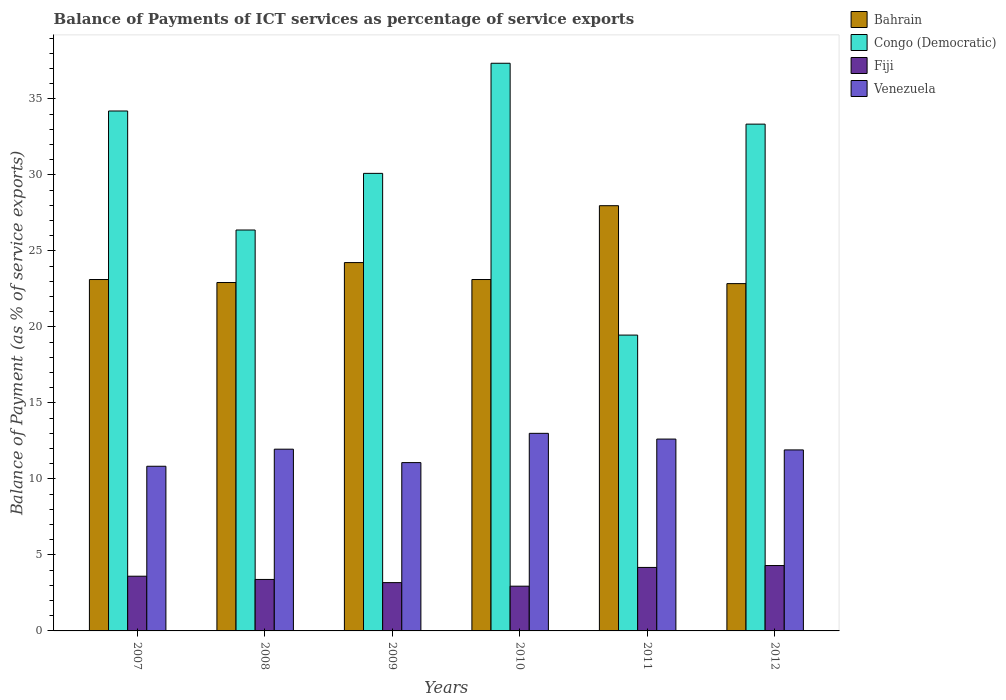Are the number of bars per tick equal to the number of legend labels?
Keep it short and to the point. Yes. Are the number of bars on each tick of the X-axis equal?
Provide a short and direct response. Yes. How many bars are there on the 4th tick from the right?
Your response must be concise. 4. In how many cases, is the number of bars for a given year not equal to the number of legend labels?
Keep it short and to the point. 0. What is the balance of payments of ICT services in Congo (Democratic) in 2009?
Ensure brevity in your answer.  30.1. Across all years, what is the maximum balance of payments of ICT services in Venezuela?
Make the answer very short. 13. Across all years, what is the minimum balance of payments of ICT services in Bahrain?
Your answer should be very brief. 22.84. In which year was the balance of payments of ICT services in Fiji maximum?
Give a very brief answer. 2012. What is the total balance of payments of ICT services in Fiji in the graph?
Provide a short and direct response. 21.58. What is the difference between the balance of payments of ICT services in Venezuela in 2007 and that in 2009?
Keep it short and to the point. -0.24. What is the difference between the balance of payments of ICT services in Venezuela in 2008 and the balance of payments of ICT services in Fiji in 2009?
Provide a short and direct response. 8.78. What is the average balance of payments of ICT services in Congo (Democratic) per year?
Your response must be concise. 30.13. In the year 2007, what is the difference between the balance of payments of ICT services in Congo (Democratic) and balance of payments of ICT services in Fiji?
Your response must be concise. 30.6. What is the ratio of the balance of payments of ICT services in Venezuela in 2007 to that in 2008?
Provide a short and direct response. 0.91. Is the balance of payments of ICT services in Venezuela in 2008 less than that in 2009?
Offer a very short reply. No. What is the difference between the highest and the second highest balance of payments of ICT services in Venezuela?
Your answer should be compact. 0.38. What is the difference between the highest and the lowest balance of payments of ICT services in Fiji?
Make the answer very short. 1.36. In how many years, is the balance of payments of ICT services in Fiji greater than the average balance of payments of ICT services in Fiji taken over all years?
Your response must be concise. 3. What does the 4th bar from the left in 2007 represents?
Your response must be concise. Venezuela. What does the 2nd bar from the right in 2011 represents?
Ensure brevity in your answer.  Fiji. How many years are there in the graph?
Keep it short and to the point. 6. Are the values on the major ticks of Y-axis written in scientific E-notation?
Keep it short and to the point. No. How many legend labels are there?
Offer a terse response. 4. What is the title of the graph?
Provide a succinct answer. Balance of Payments of ICT services as percentage of service exports. What is the label or title of the Y-axis?
Offer a terse response. Balance of Payment (as % of service exports). What is the Balance of Payment (as % of service exports) of Bahrain in 2007?
Provide a succinct answer. 23.11. What is the Balance of Payment (as % of service exports) of Congo (Democratic) in 2007?
Offer a terse response. 34.2. What is the Balance of Payment (as % of service exports) of Fiji in 2007?
Give a very brief answer. 3.6. What is the Balance of Payment (as % of service exports) in Venezuela in 2007?
Ensure brevity in your answer.  10.83. What is the Balance of Payment (as % of service exports) in Bahrain in 2008?
Offer a terse response. 22.92. What is the Balance of Payment (as % of service exports) of Congo (Democratic) in 2008?
Your answer should be very brief. 26.37. What is the Balance of Payment (as % of service exports) in Fiji in 2008?
Offer a very short reply. 3.39. What is the Balance of Payment (as % of service exports) in Venezuela in 2008?
Ensure brevity in your answer.  11.95. What is the Balance of Payment (as % of service exports) in Bahrain in 2009?
Offer a terse response. 24.23. What is the Balance of Payment (as % of service exports) of Congo (Democratic) in 2009?
Your answer should be compact. 30.1. What is the Balance of Payment (as % of service exports) of Fiji in 2009?
Keep it short and to the point. 3.18. What is the Balance of Payment (as % of service exports) of Venezuela in 2009?
Keep it short and to the point. 11.07. What is the Balance of Payment (as % of service exports) of Bahrain in 2010?
Your answer should be compact. 23.11. What is the Balance of Payment (as % of service exports) in Congo (Democratic) in 2010?
Ensure brevity in your answer.  37.34. What is the Balance of Payment (as % of service exports) in Fiji in 2010?
Give a very brief answer. 2.94. What is the Balance of Payment (as % of service exports) of Venezuela in 2010?
Make the answer very short. 13. What is the Balance of Payment (as % of service exports) in Bahrain in 2011?
Ensure brevity in your answer.  27.97. What is the Balance of Payment (as % of service exports) in Congo (Democratic) in 2011?
Keep it short and to the point. 19.46. What is the Balance of Payment (as % of service exports) of Fiji in 2011?
Ensure brevity in your answer.  4.18. What is the Balance of Payment (as % of service exports) in Venezuela in 2011?
Give a very brief answer. 12.62. What is the Balance of Payment (as % of service exports) in Bahrain in 2012?
Offer a very short reply. 22.84. What is the Balance of Payment (as % of service exports) of Congo (Democratic) in 2012?
Give a very brief answer. 33.34. What is the Balance of Payment (as % of service exports) in Fiji in 2012?
Offer a very short reply. 4.3. What is the Balance of Payment (as % of service exports) in Venezuela in 2012?
Offer a very short reply. 11.91. Across all years, what is the maximum Balance of Payment (as % of service exports) in Bahrain?
Provide a short and direct response. 27.97. Across all years, what is the maximum Balance of Payment (as % of service exports) in Congo (Democratic)?
Provide a succinct answer. 37.34. Across all years, what is the maximum Balance of Payment (as % of service exports) of Fiji?
Your answer should be very brief. 4.3. Across all years, what is the maximum Balance of Payment (as % of service exports) of Venezuela?
Your answer should be very brief. 13. Across all years, what is the minimum Balance of Payment (as % of service exports) of Bahrain?
Your response must be concise. 22.84. Across all years, what is the minimum Balance of Payment (as % of service exports) of Congo (Democratic)?
Provide a short and direct response. 19.46. Across all years, what is the minimum Balance of Payment (as % of service exports) of Fiji?
Give a very brief answer. 2.94. Across all years, what is the minimum Balance of Payment (as % of service exports) of Venezuela?
Offer a very short reply. 10.83. What is the total Balance of Payment (as % of service exports) of Bahrain in the graph?
Offer a very short reply. 144.19. What is the total Balance of Payment (as % of service exports) in Congo (Democratic) in the graph?
Ensure brevity in your answer.  180.8. What is the total Balance of Payment (as % of service exports) in Fiji in the graph?
Keep it short and to the point. 21.58. What is the total Balance of Payment (as % of service exports) of Venezuela in the graph?
Offer a very short reply. 71.38. What is the difference between the Balance of Payment (as % of service exports) of Bahrain in 2007 and that in 2008?
Your response must be concise. 0.2. What is the difference between the Balance of Payment (as % of service exports) in Congo (Democratic) in 2007 and that in 2008?
Your answer should be compact. 7.83. What is the difference between the Balance of Payment (as % of service exports) of Fiji in 2007 and that in 2008?
Provide a succinct answer. 0.21. What is the difference between the Balance of Payment (as % of service exports) of Venezuela in 2007 and that in 2008?
Your answer should be compact. -1.12. What is the difference between the Balance of Payment (as % of service exports) of Bahrain in 2007 and that in 2009?
Provide a short and direct response. -1.11. What is the difference between the Balance of Payment (as % of service exports) of Congo (Democratic) in 2007 and that in 2009?
Ensure brevity in your answer.  4.1. What is the difference between the Balance of Payment (as % of service exports) in Fiji in 2007 and that in 2009?
Offer a terse response. 0.42. What is the difference between the Balance of Payment (as % of service exports) in Venezuela in 2007 and that in 2009?
Your answer should be compact. -0.24. What is the difference between the Balance of Payment (as % of service exports) of Congo (Democratic) in 2007 and that in 2010?
Your answer should be very brief. -3.14. What is the difference between the Balance of Payment (as % of service exports) of Fiji in 2007 and that in 2010?
Your response must be concise. 0.66. What is the difference between the Balance of Payment (as % of service exports) of Venezuela in 2007 and that in 2010?
Your answer should be compact. -2.17. What is the difference between the Balance of Payment (as % of service exports) of Bahrain in 2007 and that in 2011?
Offer a very short reply. -4.86. What is the difference between the Balance of Payment (as % of service exports) in Congo (Democratic) in 2007 and that in 2011?
Offer a terse response. 14.74. What is the difference between the Balance of Payment (as % of service exports) of Fiji in 2007 and that in 2011?
Your answer should be very brief. -0.58. What is the difference between the Balance of Payment (as % of service exports) in Venezuela in 2007 and that in 2011?
Your response must be concise. -1.79. What is the difference between the Balance of Payment (as % of service exports) in Bahrain in 2007 and that in 2012?
Your answer should be compact. 0.27. What is the difference between the Balance of Payment (as % of service exports) in Congo (Democratic) in 2007 and that in 2012?
Offer a terse response. 0.86. What is the difference between the Balance of Payment (as % of service exports) of Fiji in 2007 and that in 2012?
Offer a very short reply. -0.7. What is the difference between the Balance of Payment (as % of service exports) in Venezuela in 2007 and that in 2012?
Your answer should be compact. -1.07. What is the difference between the Balance of Payment (as % of service exports) of Bahrain in 2008 and that in 2009?
Keep it short and to the point. -1.31. What is the difference between the Balance of Payment (as % of service exports) of Congo (Democratic) in 2008 and that in 2009?
Offer a very short reply. -3.73. What is the difference between the Balance of Payment (as % of service exports) of Fiji in 2008 and that in 2009?
Give a very brief answer. 0.21. What is the difference between the Balance of Payment (as % of service exports) of Venezuela in 2008 and that in 2009?
Provide a short and direct response. 0.88. What is the difference between the Balance of Payment (as % of service exports) in Bahrain in 2008 and that in 2010?
Your answer should be very brief. -0.2. What is the difference between the Balance of Payment (as % of service exports) in Congo (Democratic) in 2008 and that in 2010?
Provide a short and direct response. -10.97. What is the difference between the Balance of Payment (as % of service exports) in Fiji in 2008 and that in 2010?
Your answer should be very brief. 0.44. What is the difference between the Balance of Payment (as % of service exports) in Venezuela in 2008 and that in 2010?
Your response must be concise. -1.04. What is the difference between the Balance of Payment (as % of service exports) in Bahrain in 2008 and that in 2011?
Make the answer very short. -5.05. What is the difference between the Balance of Payment (as % of service exports) of Congo (Democratic) in 2008 and that in 2011?
Offer a terse response. 6.91. What is the difference between the Balance of Payment (as % of service exports) of Fiji in 2008 and that in 2011?
Provide a succinct answer. -0.79. What is the difference between the Balance of Payment (as % of service exports) of Venezuela in 2008 and that in 2011?
Provide a short and direct response. -0.66. What is the difference between the Balance of Payment (as % of service exports) of Bahrain in 2008 and that in 2012?
Provide a succinct answer. 0.07. What is the difference between the Balance of Payment (as % of service exports) in Congo (Democratic) in 2008 and that in 2012?
Provide a short and direct response. -6.96. What is the difference between the Balance of Payment (as % of service exports) of Fiji in 2008 and that in 2012?
Offer a terse response. -0.91. What is the difference between the Balance of Payment (as % of service exports) of Venezuela in 2008 and that in 2012?
Keep it short and to the point. 0.05. What is the difference between the Balance of Payment (as % of service exports) of Bahrain in 2009 and that in 2010?
Your response must be concise. 1.11. What is the difference between the Balance of Payment (as % of service exports) in Congo (Democratic) in 2009 and that in 2010?
Give a very brief answer. -7.24. What is the difference between the Balance of Payment (as % of service exports) of Fiji in 2009 and that in 2010?
Ensure brevity in your answer.  0.23. What is the difference between the Balance of Payment (as % of service exports) of Venezuela in 2009 and that in 2010?
Offer a terse response. -1.93. What is the difference between the Balance of Payment (as % of service exports) in Bahrain in 2009 and that in 2011?
Your response must be concise. -3.74. What is the difference between the Balance of Payment (as % of service exports) of Congo (Democratic) in 2009 and that in 2011?
Your response must be concise. 10.64. What is the difference between the Balance of Payment (as % of service exports) in Fiji in 2009 and that in 2011?
Your answer should be very brief. -1. What is the difference between the Balance of Payment (as % of service exports) in Venezuela in 2009 and that in 2011?
Your answer should be compact. -1.55. What is the difference between the Balance of Payment (as % of service exports) in Bahrain in 2009 and that in 2012?
Make the answer very short. 1.38. What is the difference between the Balance of Payment (as % of service exports) in Congo (Democratic) in 2009 and that in 2012?
Give a very brief answer. -3.24. What is the difference between the Balance of Payment (as % of service exports) in Fiji in 2009 and that in 2012?
Offer a very short reply. -1.12. What is the difference between the Balance of Payment (as % of service exports) in Venezuela in 2009 and that in 2012?
Offer a terse response. -0.83. What is the difference between the Balance of Payment (as % of service exports) of Bahrain in 2010 and that in 2011?
Offer a terse response. -4.86. What is the difference between the Balance of Payment (as % of service exports) of Congo (Democratic) in 2010 and that in 2011?
Keep it short and to the point. 17.88. What is the difference between the Balance of Payment (as % of service exports) in Fiji in 2010 and that in 2011?
Your answer should be very brief. -1.23. What is the difference between the Balance of Payment (as % of service exports) in Venezuela in 2010 and that in 2011?
Offer a very short reply. 0.38. What is the difference between the Balance of Payment (as % of service exports) of Bahrain in 2010 and that in 2012?
Your answer should be very brief. 0.27. What is the difference between the Balance of Payment (as % of service exports) in Congo (Democratic) in 2010 and that in 2012?
Your answer should be very brief. 4. What is the difference between the Balance of Payment (as % of service exports) of Fiji in 2010 and that in 2012?
Your answer should be compact. -1.36. What is the difference between the Balance of Payment (as % of service exports) in Venezuela in 2010 and that in 2012?
Your answer should be compact. 1.09. What is the difference between the Balance of Payment (as % of service exports) in Bahrain in 2011 and that in 2012?
Make the answer very short. 5.12. What is the difference between the Balance of Payment (as % of service exports) of Congo (Democratic) in 2011 and that in 2012?
Provide a short and direct response. -13.88. What is the difference between the Balance of Payment (as % of service exports) of Fiji in 2011 and that in 2012?
Offer a very short reply. -0.12. What is the difference between the Balance of Payment (as % of service exports) in Venezuela in 2011 and that in 2012?
Your response must be concise. 0.71. What is the difference between the Balance of Payment (as % of service exports) in Bahrain in 2007 and the Balance of Payment (as % of service exports) in Congo (Democratic) in 2008?
Your response must be concise. -3.26. What is the difference between the Balance of Payment (as % of service exports) in Bahrain in 2007 and the Balance of Payment (as % of service exports) in Fiji in 2008?
Keep it short and to the point. 19.73. What is the difference between the Balance of Payment (as % of service exports) in Bahrain in 2007 and the Balance of Payment (as % of service exports) in Venezuela in 2008?
Make the answer very short. 11.16. What is the difference between the Balance of Payment (as % of service exports) of Congo (Democratic) in 2007 and the Balance of Payment (as % of service exports) of Fiji in 2008?
Your response must be concise. 30.81. What is the difference between the Balance of Payment (as % of service exports) of Congo (Democratic) in 2007 and the Balance of Payment (as % of service exports) of Venezuela in 2008?
Your response must be concise. 22.25. What is the difference between the Balance of Payment (as % of service exports) of Fiji in 2007 and the Balance of Payment (as % of service exports) of Venezuela in 2008?
Your response must be concise. -8.35. What is the difference between the Balance of Payment (as % of service exports) of Bahrain in 2007 and the Balance of Payment (as % of service exports) of Congo (Democratic) in 2009?
Your response must be concise. -6.98. What is the difference between the Balance of Payment (as % of service exports) of Bahrain in 2007 and the Balance of Payment (as % of service exports) of Fiji in 2009?
Provide a succinct answer. 19.94. What is the difference between the Balance of Payment (as % of service exports) of Bahrain in 2007 and the Balance of Payment (as % of service exports) of Venezuela in 2009?
Give a very brief answer. 12.04. What is the difference between the Balance of Payment (as % of service exports) of Congo (Democratic) in 2007 and the Balance of Payment (as % of service exports) of Fiji in 2009?
Your response must be concise. 31.02. What is the difference between the Balance of Payment (as % of service exports) in Congo (Democratic) in 2007 and the Balance of Payment (as % of service exports) in Venezuela in 2009?
Provide a succinct answer. 23.13. What is the difference between the Balance of Payment (as % of service exports) of Fiji in 2007 and the Balance of Payment (as % of service exports) of Venezuela in 2009?
Ensure brevity in your answer.  -7.47. What is the difference between the Balance of Payment (as % of service exports) of Bahrain in 2007 and the Balance of Payment (as % of service exports) of Congo (Democratic) in 2010?
Offer a very short reply. -14.22. What is the difference between the Balance of Payment (as % of service exports) in Bahrain in 2007 and the Balance of Payment (as % of service exports) in Fiji in 2010?
Provide a short and direct response. 20.17. What is the difference between the Balance of Payment (as % of service exports) of Bahrain in 2007 and the Balance of Payment (as % of service exports) of Venezuela in 2010?
Give a very brief answer. 10.12. What is the difference between the Balance of Payment (as % of service exports) of Congo (Democratic) in 2007 and the Balance of Payment (as % of service exports) of Fiji in 2010?
Provide a succinct answer. 31.26. What is the difference between the Balance of Payment (as % of service exports) of Congo (Democratic) in 2007 and the Balance of Payment (as % of service exports) of Venezuela in 2010?
Your answer should be compact. 21.2. What is the difference between the Balance of Payment (as % of service exports) in Fiji in 2007 and the Balance of Payment (as % of service exports) in Venezuela in 2010?
Keep it short and to the point. -9.4. What is the difference between the Balance of Payment (as % of service exports) in Bahrain in 2007 and the Balance of Payment (as % of service exports) in Congo (Democratic) in 2011?
Make the answer very short. 3.65. What is the difference between the Balance of Payment (as % of service exports) in Bahrain in 2007 and the Balance of Payment (as % of service exports) in Fiji in 2011?
Provide a succinct answer. 18.94. What is the difference between the Balance of Payment (as % of service exports) of Bahrain in 2007 and the Balance of Payment (as % of service exports) of Venezuela in 2011?
Your response must be concise. 10.5. What is the difference between the Balance of Payment (as % of service exports) in Congo (Democratic) in 2007 and the Balance of Payment (as % of service exports) in Fiji in 2011?
Ensure brevity in your answer.  30.02. What is the difference between the Balance of Payment (as % of service exports) of Congo (Democratic) in 2007 and the Balance of Payment (as % of service exports) of Venezuela in 2011?
Ensure brevity in your answer.  21.58. What is the difference between the Balance of Payment (as % of service exports) of Fiji in 2007 and the Balance of Payment (as % of service exports) of Venezuela in 2011?
Your response must be concise. -9.02. What is the difference between the Balance of Payment (as % of service exports) of Bahrain in 2007 and the Balance of Payment (as % of service exports) of Congo (Democratic) in 2012?
Your answer should be compact. -10.22. What is the difference between the Balance of Payment (as % of service exports) in Bahrain in 2007 and the Balance of Payment (as % of service exports) in Fiji in 2012?
Offer a terse response. 18.81. What is the difference between the Balance of Payment (as % of service exports) in Bahrain in 2007 and the Balance of Payment (as % of service exports) in Venezuela in 2012?
Your response must be concise. 11.21. What is the difference between the Balance of Payment (as % of service exports) in Congo (Democratic) in 2007 and the Balance of Payment (as % of service exports) in Fiji in 2012?
Keep it short and to the point. 29.9. What is the difference between the Balance of Payment (as % of service exports) in Congo (Democratic) in 2007 and the Balance of Payment (as % of service exports) in Venezuela in 2012?
Provide a succinct answer. 22.29. What is the difference between the Balance of Payment (as % of service exports) of Fiji in 2007 and the Balance of Payment (as % of service exports) of Venezuela in 2012?
Give a very brief answer. -8.31. What is the difference between the Balance of Payment (as % of service exports) in Bahrain in 2008 and the Balance of Payment (as % of service exports) in Congo (Democratic) in 2009?
Offer a very short reply. -7.18. What is the difference between the Balance of Payment (as % of service exports) in Bahrain in 2008 and the Balance of Payment (as % of service exports) in Fiji in 2009?
Your response must be concise. 19.74. What is the difference between the Balance of Payment (as % of service exports) of Bahrain in 2008 and the Balance of Payment (as % of service exports) of Venezuela in 2009?
Give a very brief answer. 11.85. What is the difference between the Balance of Payment (as % of service exports) of Congo (Democratic) in 2008 and the Balance of Payment (as % of service exports) of Fiji in 2009?
Offer a very short reply. 23.19. What is the difference between the Balance of Payment (as % of service exports) in Congo (Democratic) in 2008 and the Balance of Payment (as % of service exports) in Venezuela in 2009?
Your response must be concise. 15.3. What is the difference between the Balance of Payment (as % of service exports) in Fiji in 2008 and the Balance of Payment (as % of service exports) in Venezuela in 2009?
Keep it short and to the point. -7.69. What is the difference between the Balance of Payment (as % of service exports) of Bahrain in 2008 and the Balance of Payment (as % of service exports) of Congo (Democratic) in 2010?
Ensure brevity in your answer.  -14.42. What is the difference between the Balance of Payment (as % of service exports) in Bahrain in 2008 and the Balance of Payment (as % of service exports) in Fiji in 2010?
Make the answer very short. 19.97. What is the difference between the Balance of Payment (as % of service exports) of Bahrain in 2008 and the Balance of Payment (as % of service exports) of Venezuela in 2010?
Make the answer very short. 9.92. What is the difference between the Balance of Payment (as % of service exports) in Congo (Democratic) in 2008 and the Balance of Payment (as % of service exports) in Fiji in 2010?
Keep it short and to the point. 23.43. What is the difference between the Balance of Payment (as % of service exports) in Congo (Democratic) in 2008 and the Balance of Payment (as % of service exports) in Venezuela in 2010?
Offer a very short reply. 13.37. What is the difference between the Balance of Payment (as % of service exports) in Fiji in 2008 and the Balance of Payment (as % of service exports) in Venezuela in 2010?
Keep it short and to the point. -9.61. What is the difference between the Balance of Payment (as % of service exports) of Bahrain in 2008 and the Balance of Payment (as % of service exports) of Congo (Democratic) in 2011?
Provide a short and direct response. 3.46. What is the difference between the Balance of Payment (as % of service exports) in Bahrain in 2008 and the Balance of Payment (as % of service exports) in Fiji in 2011?
Make the answer very short. 18.74. What is the difference between the Balance of Payment (as % of service exports) in Bahrain in 2008 and the Balance of Payment (as % of service exports) in Venezuela in 2011?
Your response must be concise. 10.3. What is the difference between the Balance of Payment (as % of service exports) in Congo (Democratic) in 2008 and the Balance of Payment (as % of service exports) in Fiji in 2011?
Ensure brevity in your answer.  22.19. What is the difference between the Balance of Payment (as % of service exports) in Congo (Democratic) in 2008 and the Balance of Payment (as % of service exports) in Venezuela in 2011?
Your answer should be very brief. 13.75. What is the difference between the Balance of Payment (as % of service exports) in Fiji in 2008 and the Balance of Payment (as % of service exports) in Venezuela in 2011?
Offer a terse response. -9.23. What is the difference between the Balance of Payment (as % of service exports) in Bahrain in 2008 and the Balance of Payment (as % of service exports) in Congo (Democratic) in 2012?
Your answer should be very brief. -10.42. What is the difference between the Balance of Payment (as % of service exports) in Bahrain in 2008 and the Balance of Payment (as % of service exports) in Fiji in 2012?
Your answer should be compact. 18.62. What is the difference between the Balance of Payment (as % of service exports) of Bahrain in 2008 and the Balance of Payment (as % of service exports) of Venezuela in 2012?
Your answer should be compact. 11.01. What is the difference between the Balance of Payment (as % of service exports) of Congo (Democratic) in 2008 and the Balance of Payment (as % of service exports) of Fiji in 2012?
Keep it short and to the point. 22.07. What is the difference between the Balance of Payment (as % of service exports) in Congo (Democratic) in 2008 and the Balance of Payment (as % of service exports) in Venezuela in 2012?
Your response must be concise. 14.46. What is the difference between the Balance of Payment (as % of service exports) in Fiji in 2008 and the Balance of Payment (as % of service exports) in Venezuela in 2012?
Your response must be concise. -8.52. What is the difference between the Balance of Payment (as % of service exports) in Bahrain in 2009 and the Balance of Payment (as % of service exports) in Congo (Democratic) in 2010?
Your answer should be compact. -13.11. What is the difference between the Balance of Payment (as % of service exports) in Bahrain in 2009 and the Balance of Payment (as % of service exports) in Fiji in 2010?
Provide a succinct answer. 21.28. What is the difference between the Balance of Payment (as % of service exports) of Bahrain in 2009 and the Balance of Payment (as % of service exports) of Venezuela in 2010?
Keep it short and to the point. 11.23. What is the difference between the Balance of Payment (as % of service exports) of Congo (Democratic) in 2009 and the Balance of Payment (as % of service exports) of Fiji in 2010?
Your response must be concise. 27.15. What is the difference between the Balance of Payment (as % of service exports) in Congo (Democratic) in 2009 and the Balance of Payment (as % of service exports) in Venezuela in 2010?
Your answer should be compact. 17.1. What is the difference between the Balance of Payment (as % of service exports) in Fiji in 2009 and the Balance of Payment (as % of service exports) in Venezuela in 2010?
Provide a short and direct response. -9.82. What is the difference between the Balance of Payment (as % of service exports) in Bahrain in 2009 and the Balance of Payment (as % of service exports) in Congo (Democratic) in 2011?
Provide a succinct answer. 4.77. What is the difference between the Balance of Payment (as % of service exports) in Bahrain in 2009 and the Balance of Payment (as % of service exports) in Fiji in 2011?
Offer a very short reply. 20.05. What is the difference between the Balance of Payment (as % of service exports) in Bahrain in 2009 and the Balance of Payment (as % of service exports) in Venezuela in 2011?
Offer a very short reply. 11.61. What is the difference between the Balance of Payment (as % of service exports) in Congo (Democratic) in 2009 and the Balance of Payment (as % of service exports) in Fiji in 2011?
Make the answer very short. 25.92. What is the difference between the Balance of Payment (as % of service exports) in Congo (Democratic) in 2009 and the Balance of Payment (as % of service exports) in Venezuela in 2011?
Your answer should be very brief. 17.48. What is the difference between the Balance of Payment (as % of service exports) in Fiji in 2009 and the Balance of Payment (as % of service exports) in Venezuela in 2011?
Your answer should be very brief. -9.44. What is the difference between the Balance of Payment (as % of service exports) in Bahrain in 2009 and the Balance of Payment (as % of service exports) in Congo (Democratic) in 2012?
Offer a terse response. -9.11. What is the difference between the Balance of Payment (as % of service exports) of Bahrain in 2009 and the Balance of Payment (as % of service exports) of Fiji in 2012?
Your answer should be very brief. 19.93. What is the difference between the Balance of Payment (as % of service exports) of Bahrain in 2009 and the Balance of Payment (as % of service exports) of Venezuela in 2012?
Make the answer very short. 12.32. What is the difference between the Balance of Payment (as % of service exports) of Congo (Democratic) in 2009 and the Balance of Payment (as % of service exports) of Fiji in 2012?
Ensure brevity in your answer.  25.8. What is the difference between the Balance of Payment (as % of service exports) of Congo (Democratic) in 2009 and the Balance of Payment (as % of service exports) of Venezuela in 2012?
Provide a succinct answer. 18.19. What is the difference between the Balance of Payment (as % of service exports) of Fiji in 2009 and the Balance of Payment (as % of service exports) of Venezuela in 2012?
Your answer should be very brief. -8.73. What is the difference between the Balance of Payment (as % of service exports) in Bahrain in 2010 and the Balance of Payment (as % of service exports) in Congo (Democratic) in 2011?
Provide a short and direct response. 3.65. What is the difference between the Balance of Payment (as % of service exports) in Bahrain in 2010 and the Balance of Payment (as % of service exports) in Fiji in 2011?
Provide a succinct answer. 18.94. What is the difference between the Balance of Payment (as % of service exports) of Bahrain in 2010 and the Balance of Payment (as % of service exports) of Venezuela in 2011?
Your response must be concise. 10.49. What is the difference between the Balance of Payment (as % of service exports) in Congo (Democratic) in 2010 and the Balance of Payment (as % of service exports) in Fiji in 2011?
Offer a terse response. 33.16. What is the difference between the Balance of Payment (as % of service exports) in Congo (Democratic) in 2010 and the Balance of Payment (as % of service exports) in Venezuela in 2011?
Ensure brevity in your answer.  24.72. What is the difference between the Balance of Payment (as % of service exports) in Fiji in 2010 and the Balance of Payment (as % of service exports) in Venezuela in 2011?
Offer a terse response. -9.68. What is the difference between the Balance of Payment (as % of service exports) in Bahrain in 2010 and the Balance of Payment (as % of service exports) in Congo (Democratic) in 2012?
Provide a succinct answer. -10.22. What is the difference between the Balance of Payment (as % of service exports) in Bahrain in 2010 and the Balance of Payment (as % of service exports) in Fiji in 2012?
Ensure brevity in your answer.  18.81. What is the difference between the Balance of Payment (as % of service exports) of Bahrain in 2010 and the Balance of Payment (as % of service exports) of Venezuela in 2012?
Give a very brief answer. 11.21. What is the difference between the Balance of Payment (as % of service exports) of Congo (Democratic) in 2010 and the Balance of Payment (as % of service exports) of Fiji in 2012?
Your response must be concise. 33.04. What is the difference between the Balance of Payment (as % of service exports) of Congo (Democratic) in 2010 and the Balance of Payment (as % of service exports) of Venezuela in 2012?
Your answer should be very brief. 25.43. What is the difference between the Balance of Payment (as % of service exports) in Fiji in 2010 and the Balance of Payment (as % of service exports) in Venezuela in 2012?
Give a very brief answer. -8.96. What is the difference between the Balance of Payment (as % of service exports) of Bahrain in 2011 and the Balance of Payment (as % of service exports) of Congo (Democratic) in 2012?
Your answer should be very brief. -5.37. What is the difference between the Balance of Payment (as % of service exports) in Bahrain in 2011 and the Balance of Payment (as % of service exports) in Fiji in 2012?
Your answer should be very brief. 23.67. What is the difference between the Balance of Payment (as % of service exports) of Bahrain in 2011 and the Balance of Payment (as % of service exports) of Venezuela in 2012?
Keep it short and to the point. 16.06. What is the difference between the Balance of Payment (as % of service exports) of Congo (Democratic) in 2011 and the Balance of Payment (as % of service exports) of Fiji in 2012?
Make the answer very short. 15.16. What is the difference between the Balance of Payment (as % of service exports) in Congo (Democratic) in 2011 and the Balance of Payment (as % of service exports) in Venezuela in 2012?
Offer a terse response. 7.55. What is the difference between the Balance of Payment (as % of service exports) of Fiji in 2011 and the Balance of Payment (as % of service exports) of Venezuela in 2012?
Keep it short and to the point. -7.73. What is the average Balance of Payment (as % of service exports) of Bahrain per year?
Your answer should be compact. 24.03. What is the average Balance of Payment (as % of service exports) of Congo (Democratic) per year?
Provide a succinct answer. 30.13. What is the average Balance of Payment (as % of service exports) of Fiji per year?
Offer a terse response. 3.6. What is the average Balance of Payment (as % of service exports) in Venezuela per year?
Offer a very short reply. 11.9. In the year 2007, what is the difference between the Balance of Payment (as % of service exports) in Bahrain and Balance of Payment (as % of service exports) in Congo (Democratic)?
Your response must be concise. -11.09. In the year 2007, what is the difference between the Balance of Payment (as % of service exports) of Bahrain and Balance of Payment (as % of service exports) of Fiji?
Provide a short and direct response. 19.52. In the year 2007, what is the difference between the Balance of Payment (as % of service exports) in Bahrain and Balance of Payment (as % of service exports) in Venezuela?
Make the answer very short. 12.28. In the year 2007, what is the difference between the Balance of Payment (as % of service exports) of Congo (Democratic) and Balance of Payment (as % of service exports) of Fiji?
Offer a terse response. 30.6. In the year 2007, what is the difference between the Balance of Payment (as % of service exports) in Congo (Democratic) and Balance of Payment (as % of service exports) in Venezuela?
Provide a succinct answer. 23.37. In the year 2007, what is the difference between the Balance of Payment (as % of service exports) in Fiji and Balance of Payment (as % of service exports) in Venezuela?
Your answer should be compact. -7.23. In the year 2008, what is the difference between the Balance of Payment (as % of service exports) of Bahrain and Balance of Payment (as % of service exports) of Congo (Democratic)?
Offer a terse response. -3.45. In the year 2008, what is the difference between the Balance of Payment (as % of service exports) of Bahrain and Balance of Payment (as % of service exports) of Fiji?
Provide a short and direct response. 19.53. In the year 2008, what is the difference between the Balance of Payment (as % of service exports) of Bahrain and Balance of Payment (as % of service exports) of Venezuela?
Provide a succinct answer. 10.96. In the year 2008, what is the difference between the Balance of Payment (as % of service exports) of Congo (Democratic) and Balance of Payment (as % of service exports) of Fiji?
Your answer should be very brief. 22.98. In the year 2008, what is the difference between the Balance of Payment (as % of service exports) of Congo (Democratic) and Balance of Payment (as % of service exports) of Venezuela?
Your response must be concise. 14.42. In the year 2008, what is the difference between the Balance of Payment (as % of service exports) in Fiji and Balance of Payment (as % of service exports) in Venezuela?
Make the answer very short. -8.57. In the year 2009, what is the difference between the Balance of Payment (as % of service exports) in Bahrain and Balance of Payment (as % of service exports) in Congo (Democratic)?
Make the answer very short. -5.87. In the year 2009, what is the difference between the Balance of Payment (as % of service exports) of Bahrain and Balance of Payment (as % of service exports) of Fiji?
Your answer should be compact. 21.05. In the year 2009, what is the difference between the Balance of Payment (as % of service exports) in Bahrain and Balance of Payment (as % of service exports) in Venezuela?
Keep it short and to the point. 13.16. In the year 2009, what is the difference between the Balance of Payment (as % of service exports) of Congo (Democratic) and Balance of Payment (as % of service exports) of Fiji?
Give a very brief answer. 26.92. In the year 2009, what is the difference between the Balance of Payment (as % of service exports) of Congo (Democratic) and Balance of Payment (as % of service exports) of Venezuela?
Provide a short and direct response. 19.03. In the year 2009, what is the difference between the Balance of Payment (as % of service exports) of Fiji and Balance of Payment (as % of service exports) of Venezuela?
Provide a short and direct response. -7.89. In the year 2010, what is the difference between the Balance of Payment (as % of service exports) in Bahrain and Balance of Payment (as % of service exports) in Congo (Democratic)?
Your response must be concise. -14.23. In the year 2010, what is the difference between the Balance of Payment (as % of service exports) of Bahrain and Balance of Payment (as % of service exports) of Fiji?
Ensure brevity in your answer.  20.17. In the year 2010, what is the difference between the Balance of Payment (as % of service exports) of Bahrain and Balance of Payment (as % of service exports) of Venezuela?
Your answer should be compact. 10.12. In the year 2010, what is the difference between the Balance of Payment (as % of service exports) in Congo (Democratic) and Balance of Payment (as % of service exports) in Fiji?
Provide a succinct answer. 34.4. In the year 2010, what is the difference between the Balance of Payment (as % of service exports) in Congo (Democratic) and Balance of Payment (as % of service exports) in Venezuela?
Provide a short and direct response. 24.34. In the year 2010, what is the difference between the Balance of Payment (as % of service exports) in Fiji and Balance of Payment (as % of service exports) in Venezuela?
Provide a succinct answer. -10.05. In the year 2011, what is the difference between the Balance of Payment (as % of service exports) of Bahrain and Balance of Payment (as % of service exports) of Congo (Democratic)?
Make the answer very short. 8.51. In the year 2011, what is the difference between the Balance of Payment (as % of service exports) in Bahrain and Balance of Payment (as % of service exports) in Fiji?
Ensure brevity in your answer.  23.79. In the year 2011, what is the difference between the Balance of Payment (as % of service exports) in Bahrain and Balance of Payment (as % of service exports) in Venezuela?
Your answer should be compact. 15.35. In the year 2011, what is the difference between the Balance of Payment (as % of service exports) of Congo (Democratic) and Balance of Payment (as % of service exports) of Fiji?
Provide a short and direct response. 15.28. In the year 2011, what is the difference between the Balance of Payment (as % of service exports) in Congo (Democratic) and Balance of Payment (as % of service exports) in Venezuela?
Provide a succinct answer. 6.84. In the year 2011, what is the difference between the Balance of Payment (as % of service exports) in Fiji and Balance of Payment (as % of service exports) in Venezuela?
Your response must be concise. -8.44. In the year 2012, what is the difference between the Balance of Payment (as % of service exports) of Bahrain and Balance of Payment (as % of service exports) of Congo (Democratic)?
Make the answer very short. -10.49. In the year 2012, what is the difference between the Balance of Payment (as % of service exports) in Bahrain and Balance of Payment (as % of service exports) in Fiji?
Keep it short and to the point. 18.54. In the year 2012, what is the difference between the Balance of Payment (as % of service exports) of Bahrain and Balance of Payment (as % of service exports) of Venezuela?
Offer a very short reply. 10.94. In the year 2012, what is the difference between the Balance of Payment (as % of service exports) in Congo (Democratic) and Balance of Payment (as % of service exports) in Fiji?
Offer a very short reply. 29.03. In the year 2012, what is the difference between the Balance of Payment (as % of service exports) in Congo (Democratic) and Balance of Payment (as % of service exports) in Venezuela?
Provide a short and direct response. 21.43. In the year 2012, what is the difference between the Balance of Payment (as % of service exports) of Fiji and Balance of Payment (as % of service exports) of Venezuela?
Give a very brief answer. -7.61. What is the ratio of the Balance of Payment (as % of service exports) in Bahrain in 2007 to that in 2008?
Make the answer very short. 1.01. What is the ratio of the Balance of Payment (as % of service exports) in Congo (Democratic) in 2007 to that in 2008?
Offer a very short reply. 1.3. What is the ratio of the Balance of Payment (as % of service exports) in Fiji in 2007 to that in 2008?
Give a very brief answer. 1.06. What is the ratio of the Balance of Payment (as % of service exports) of Venezuela in 2007 to that in 2008?
Your answer should be very brief. 0.91. What is the ratio of the Balance of Payment (as % of service exports) of Bahrain in 2007 to that in 2009?
Make the answer very short. 0.95. What is the ratio of the Balance of Payment (as % of service exports) in Congo (Democratic) in 2007 to that in 2009?
Your answer should be very brief. 1.14. What is the ratio of the Balance of Payment (as % of service exports) in Fiji in 2007 to that in 2009?
Offer a terse response. 1.13. What is the ratio of the Balance of Payment (as % of service exports) of Venezuela in 2007 to that in 2009?
Give a very brief answer. 0.98. What is the ratio of the Balance of Payment (as % of service exports) in Bahrain in 2007 to that in 2010?
Provide a succinct answer. 1. What is the ratio of the Balance of Payment (as % of service exports) of Congo (Democratic) in 2007 to that in 2010?
Provide a succinct answer. 0.92. What is the ratio of the Balance of Payment (as % of service exports) in Fiji in 2007 to that in 2010?
Your response must be concise. 1.22. What is the ratio of the Balance of Payment (as % of service exports) of Venezuela in 2007 to that in 2010?
Offer a very short reply. 0.83. What is the ratio of the Balance of Payment (as % of service exports) of Bahrain in 2007 to that in 2011?
Make the answer very short. 0.83. What is the ratio of the Balance of Payment (as % of service exports) of Congo (Democratic) in 2007 to that in 2011?
Your answer should be very brief. 1.76. What is the ratio of the Balance of Payment (as % of service exports) in Fiji in 2007 to that in 2011?
Your response must be concise. 0.86. What is the ratio of the Balance of Payment (as % of service exports) in Venezuela in 2007 to that in 2011?
Offer a very short reply. 0.86. What is the ratio of the Balance of Payment (as % of service exports) of Bahrain in 2007 to that in 2012?
Offer a very short reply. 1.01. What is the ratio of the Balance of Payment (as % of service exports) of Congo (Democratic) in 2007 to that in 2012?
Offer a very short reply. 1.03. What is the ratio of the Balance of Payment (as % of service exports) in Fiji in 2007 to that in 2012?
Offer a very short reply. 0.84. What is the ratio of the Balance of Payment (as % of service exports) of Venezuela in 2007 to that in 2012?
Your response must be concise. 0.91. What is the ratio of the Balance of Payment (as % of service exports) of Bahrain in 2008 to that in 2009?
Offer a terse response. 0.95. What is the ratio of the Balance of Payment (as % of service exports) in Congo (Democratic) in 2008 to that in 2009?
Your answer should be compact. 0.88. What is the ratio of the Balance of Payment (as % of service exports) in Fiji in 2008 to that in 2009?
Ensure brevity in your answer.  1.07. What is the ratio of the Balance of Payment (as % of service exports) of Venezuela in 2008 to that in 2009?
Make the answer very short. 1.08. What is the ratio of the Balance of Payment (as % of service exports) of Bahrain in 2008 to that in 2010?
Give a very brief answer. 0.99. What is the ratio of the Balance of Payment (as % of service exports) of Congo (Democratic) in 2008 to that in 2010?
Provide a succinct answer. 0.71. What is the ratio of the Balance of Payment (as % of service exports) of Fiji in 2008 to that in 2010?
Offer a terse response. 1.15. What is the ratio of the Balance of Payment (as % of service exports) in Venezuela in 2008 to that in 2010?
Provide a succinct answer. 0.92. What is the ratio of the Balance of Payment (as % of service exports) of Bahrain in 2008 to that in 2011?
Make the answer very short. 0.82. What is the ratio of the Balance of Payment (as % of service exports) of Congo (Democratic) in 2008 to that in 2011?
Offer a terse response. 1.36. What is the ratio of the Balance of Payment (as % of service exports) in Fiji in 2008 to that in 2011?
Make the answer very short. 0.81. What is the ratio of the Balance of Payment (as % of service exports) in Venezuela in 2008 to that in 2011?
Your answer should be very brief. 0.95. What is the ratio of the Balance of Payment (as % of service exports) of Bahrain in 2008 to that in 2012?
Your response must be concise. 1. What is the ratio of the Balance of Payment (as % of service exports) in Congo (Democratic) in 2008 to that in 2012?
Provide a short and direct response. 0.79. What is the ratio of the Balance of Payment (as % of service exports) in Fiji in 2008 to that in 2012?
Ensure brevity in your answer.  0.79. What is the ratio of the Balance of Payment (as % of service exports) in Bahrain in 2009 to that in 2010?
Give a very brief answer. 1.05. What is the ratio of the Balance of Payment (as % of service exports) in Congo (Democratic) in 2009 to that in 2010?
Keep it short and to the point. 0.81. What is the ratio of the Balance of Payment (as % of service exports) of Fiji in 2009 to that in 2010?
Your response must be concise. 1.08. What is the ratio of the Balance of Payment (as % of service exports) in Venezuela in 2009 to that in 2010?
Your response must be concise. 0.85. What is the ratio of the Balance of Payment (as % of service exports) of Bahrain in 2009 to that in 2011?
Give a very brief answer. 0.87. What is the ratio of the Balance of Payment (as % of service exports) in Congo (Democratic) in 2009 to that in 2011?
Keep it short and to the point. 1.55. What is the ratio of the Balance of Payment (as % of service exports) in Fiji in 2009 to that in 2011?
Your answer should be compact. 0.76. What is the ratio of the Balance of Payment (as % of service exports) in Venezuela in 2009 to that in 2011?
Offer a terse response. 0.88. What is the ratio of the Balance of Payment (as % of service exports) in Bahrain in 2009 to that in 2012?
Ensure brevity in your answer.  1.06. What is the ratio of the Balance of Payment (as % of service exports) of Congo (Democratic) in 2009 to that in 2012?
Make the answer very short. 0.9. What is the ratio of the Balance of Payment (as % of service exports) of Fiji in 2009 to that in 2012?
Offer a very short reply. 0.74. What is the ratio of the Balance of Payment (as % of service exports) in Venezuela in 2009 to that in 2012?
Ensure brevity in your answer.  0.93. What is the ratio of the Balance of Payment (as % of service exports) in Bahrain in 2010 to that in 2011?
Offer a very short reply. 0.83. What is the ratio of the Balance of Payment (as % of service exports) in Congo (Democratic) in 2010 to that in 2011?
Offer a terse response. 1.92. What is the ratio of the Balance of Payment (as % of service exports) in Fiji in 2010 to that in 2011?
Provide a short and direct response. 0.7. What is the ratio of the Balance of Payment (as % of service exports) of Venezuela in 2010 to that in 2011?
Offer a terse response. 1.03. What is the ratio of the Balance of Payment (as % of service exports) in Bahrain in 2010 to that in 2012?
Ensure brevity in your answer.  1.01. What is the ratio of the Balance of Payment (as % of service exports) of Congo (Democratic) in 2010 to that in 2012?
Provide a succinct answer. 1.12. What is the ratio of the Balance of Payment (as % of service exports) in Fiji in 2010 to that in 2012?
Provide a short and direct response. 0.68. What is the ratio of the Balance of Payment (as % of service exports) of Venezuela in 2010 to that in 2012?
Offer a very short reply. 1.09. What is the ratio of the Balance of Payment (as % of service exports) of Bahrain in 2011 to that in 2012?
Your response must be concise. 1.22. What is the ratio of the Balance of Payment (as % of service exports) of Congo (Democratic) in 2011 to that in 2012?
Your answer should be compact. 0.58. What is the ratio of the Balance of Payment (as % of service exports) in Fiji in 2011 to that in 2012?
Your answer should be compact. 0.97. What is the ratio of the Balance of Payment (as % of service exports) in Venezuela in 2011 to that in 2012?
Your response must be concise. 1.06. What is the difference between the highest and the second highest Balance of Payment (as % of service exports) in Bahrain?
Make the answer very short. 3.74. What is the difference between the highest and the second highest Balance of Payment (as % of service exports) of Congo (Democratic)?
Provide a succinct answer. 3.14. What is the difference between the highest and the second highest Balance of Payment (as % of service exports) in Fiji?
Offer a terse response. 0.12. What is the difference between the highest and the second highest Balance of Payment (as % of service exports) in Venezuela?
Your response must be concise. 0.38. What is the difference between the highest and the lowest Balance of Payment (as % of service exports) of Bahrain?
Make the answer very short. 5.12. What is the difference between the highest and the lowest Balance of Payment (as % of service exports) in Congo (Democratic)?
Ensure brevity in your answer.  17.88. What is the difference between the highest and the lowest Balance of Payment (as % of service exports) of Fiji?
Provide a succinct answer. 1.36. What is the difference between the highest and the lowest Balance of Payment (as % of service exports) of Venezuela?
Your answer should be very brief. 2.17. 